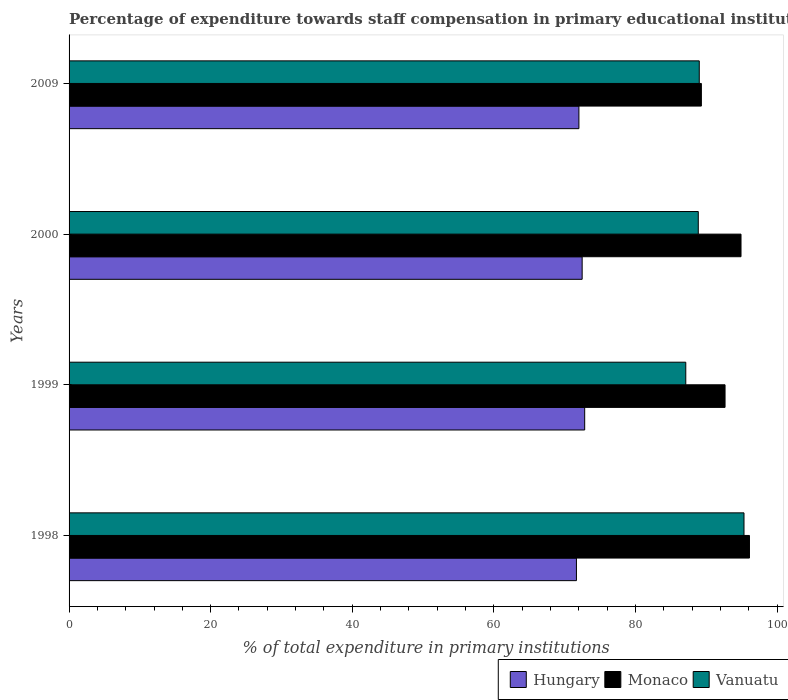How many groups of bars are there?
Offer a very short reply. 4. Are the number of bars on each tick of the Y-axis equal?
Ensure brevity in your answer.  Yes. How many bars are there on the 3rd tick from the bottom?
Make the answer very short. 3. In how many cases, is the number of bars for a given year not equal to the number of legend labels?
Your answer should be compact. 0. What is the percentage of expenditure towards staff compensation in Monaco in 2000?
Give a very brief answer. 94.91. Across all years, what is the maximum percentage of expenditure towards staff compensation in Hungary?
Your response must be concise. 72.83. Across all years, what is the minimum percentage of expenditure towards staff compensation in Hungary?
Make the answer very short. 71.66. What is the total percentage of expenditure towards staff compensation in Monaco in the graph?
Offer a terse response. 372.98. What is the difference between the percentage of expenditure towards staff compensation in Hungary in 1998 and that in 2009?
Make the answer very short. -0.35. What is the difference between the percentage of expenditure towards staff compensation in Monaco in 2009 and the percentage of expenditure towards staff compensation in Vanuatu in 2000?
Make the answer very short. 0.44. What is the average percentage of expenditure towards staff compensation in Hungary per year?
Your answer should be compact. 72.24. In the year 2000, what is the difference between the percentage of expenditure towards staff compensation in Hungary and percentage of expenditure towards staff compensation in Vanuatu?
Provide a succinct answer. -16.4. In how many years, is the percentage of expenditure towards staff compensation in Monaco greater than 92 %?
Ensure brevity in your answer.  3. What is the ratio of the percentage of expenditure towards staff compensation in Monaco in 1998 to that in 1999?
Give a very brief answer. 1.04. Is the difference between the percentage of expenditure towards staff compensation in Hungary in 1999 and 2000 greater than the difference between the percentage of expenditure towards staff compensation in Vanuatu in 1999 and 2000?
Provide a short and direct response. Yes. What is the difference between the highest and the second highest percentage of expenditure towards staff compensation in Vanuatu?
Ensure brevity in your answer.  6.32. What is the difference between the highest and the lowest percentage of expenditure towards staff compensation in Hungary?
Provide a succinct answer. 1.17. What does the 1st bar from the top in 1998 represents?
Give a very brief answer. Vanuatu. What does the 1st bar from the bottom in 2000 represents?
Offer a terse response. Hungary. Is it the case that in every year, the sum of the percentage of expenditure towards staff compensation in Hungary and percentage of expenditure towards staff compensation in Vanuatu is greater than the percentage of expenditure towards staff compensation in Monaco?
Give a very brief answer. Yes. How many bars are there?
Offer a very short reply. 12. Are all the bars in the graph horizontal?
Provide a short and direct response. Yes. How many years are there in the graph?
Your answer should be compact. 4. What is the difference between two consecutive major ticks on the X-axis?
Ensure brevity in your answer.  20. Are the values on the major ticks of X-axis written in scientific E-notation?
Your answer should be compact. No. Does the graph contain grids?
Your answer should be compact. No. Where does the legend appear in the graph?
Your answer should be compact. Bottom right. How are the legend labels stacked?
Offer a terse response. Horizontal. What is the title of the graph?
Offer a terse response. Percentage of expenditure towards staff compensation in primary educational institutions. Does "Libya" appear as one of the legend labels in the graph?
Provide a succinct answer. No. What is the label or title of the X-axis?
Make the answer very short. % of total expenditure in primary institutions. What is the label or title of the Y-axis?
Give a very brief answer. Years. What is the % of total expenditure in primary institutions in Hungary in 1998?
Provide a short and direct response. 71.66. What is the % of total expenditure in primary institutions in Monaco in 1998?
Ensure brevity in your answer.  96.1. What is the % of total expenditure in primary institutions in Vanuatu in 1998?
Provide a succinct answer. 95.33. What is the % of total expenditure in primary institutions in Hungary in 1999?
Keep it short and to the point. 72.83. What is the % of total expenditure in primary institutions of Monaco in 1999?
Make the answer very short. 92.65. What is the % of total expenditure in primary institutions of Vanuatu in 1999?
Provide a succinct answer. 87.11. What is the % of total expenditure in primary institutions of Hungary in 2000?
Provide a short and direct response. 72.47. What is the % of total expenditure in primary institutions of Monaco in 2000?
Your answer should be very brief. 94.91. What is the % of total expenditure in primary institutions of Vanuatu in 2000?
Provide a short and direct response. 88.87. What is the % of total expenditure in primary institutions in Hungary in 2009?
Offer a very short reply. 72.01. What is the % of total expenditure in primary institutions of Monaco in 2009?
Offer a terse response. 89.31. What is the % of total expenditure in primary institutions in Vanuatu in 2009?
Offer a terse response. 89.01. Across all years, what is the maximum % of total expenditure in primary institutions in Hungary?
Keep it short and to the point. 72.83. Across all years, what is the maximum % of total expenditure in primary institutions in Monaco?
Your answer should be compact. 96.1. Across all years, what is the maximum % of total expenditure in primary institutions in Vanuatu?
Give a very brief answer. 95.33. Across all years, what is the minimum % of total expenditure in primary institutions of Hungary?
Provide a succinct answer. 71.66. Across all years, what is the minimum % of total expenditure in primary institutions in Monaco?
Your response must be concise. 89.31. Across all years, what is the minimum % of total expenditure in primary institutions in Vanuatu?
Provide a short and direct response. 87.11. What is the total % of total expenditure in primary institutions in Hungary in the graph?
Your answer should be compact. 288.97. What is the total % of total expenditure in primary institutions in Monaco in the graph?
Offer a very short reply. 372.98. What is the total % of total expenditure in primary institutions of Vanuatu in the graph?
Provide a succinct answer. 360.32. What is the difference between the % of total expenditure in primary institutions of Hungary in 1998 and that in 1999?
Make the answer very short. -1.17. What is the difference between the % of total expenditure in primary institutions in Monaco in 1998 and that in 1999?
Give a very brief answer. 3.45. What is the difference between the % of total expenditure in primary institutions in Vanuatu in 1998 and that in 1999?
Ensure brevity in your answer.  8.22. What is the difference between the % of total expenditure in primary institutions in Hungary in 1998 and that in 2000?
Keep it short and to the point. -0.81. What is the difference between the % of total expenditure in primary institutions of Monaco in 1998 and that in 2000?
Provide a short and direct response. 1.2. What is the difference between the % of total expenditure in primary institutions in Vanuatu in 1998 and that in 2000?
Your answer should be very brief. 6.46. What is the difference between the % of total expenditure in primary institutions of Hungary in 1998 and that in 2009?
Offer a terse response. -0.35. What is the difference between the % of total expenditure in primary institutions in Monaco in 1998 and that in 2009?
Offer a very short reply. 6.79. What is the difference between the % of total expenditure in primary institutions of Vanuatu in 1998 and that in 2009?
Make the answer very short. 6.32. What is the difference between the % of total expenditure in primary institutions in Hungary in 1999 and that in 2000?
Offer a terse response. 0.36. What is the difference between the % of total expenditure in primary institutions of Monaco in 1999 and that in 2000?
Ensure brevity in your answer.  -2.25. What is the difference between the % of total expenditure in primary institutions of Vanuatu in 1999 and that in 2000?
Your answer should be compact. -1.77. What is the difference between the % of total expenditure in primary institutions in Hungary in 1999 and that in 2009?
Your answer should be compact. 0.82. What is the difference between the % of total expenditure in primary institutions of Monaco in 1999 and that in 2009?
Your answer should be very brief. 3.34. What is the difference between the % of total expenditure in primary institutions of Vanuatu in 1999 and that in 2009?
Provide a succinct answer. -1.9. What is the difference between the % of total expenditure in primary institutions in Hungary in 2000 and that in 2009?
Offer a very short reply. 0.46. What is the difference between the % of total expenditure in primary institutions in Monaco in 2000 and that in 2009?
Ensure brevity in your answer.  5.6. What is the difference between the % of total expenditure in primary institutions of Vanuatu in 2000 and that in 2009?
Provide a succinct answer. -0.14. What is the difference between the % of total expenditure in primary institutions in Hungary in 1998 and the % of total expenditure in primary institutions in Monaco in 1999?
Give a very brief answer. -20.99. What is the difference between the % of total expenditure in primary institutions in Hungary in 1998 and the % of total expenditure in primary institutions in Vanuatu in 1999?
Your response must be concise. -15.45. What is the difference between the % of total expenditure in primary institutions in Monaco in 1998 and the % of total expenditure in primary institutions in Vanuatu in 1999?
Provide a succinct answer. 9. What is the difference between the % of total expenditure in primary institutions in Hungary in 1998 and the % of total expenditure in primary institutions in Monaco in 2000?
Give a very brief answer. -23.25. What is the difference between the % of total expenditure in primary institutions in Hungary in 1998 and the % of total expenditure in primary institutions in Vanuatu in 2000?
Provide a short and direct response. -17.21. What is the difference between the % of total expenditure in primary institutions of Monaco in 1998 and the % of total expenditure in primary institutions of Vanuatu in 2000?
Keep it short and to the point. 7.23. What is the difference between the % of total expenditure in primary institutions in Hungary in 1998 and the % of total expenditure in primary institutions in Monaco in 2009?
Ensure brevity in your answer.  -17.65. What is the difference between the % of total expenditure in primary institutions of Hungary in 1998 and the % of total expenditure in primary institutions of Vanuatu in 2009?
Your response must be concise. -17.35. What is the difference between the % of total expenditure in primary institutions in Monaco in 1998 and the % of total expenditure in primary institutions in Vanuatu in 2009?
Offer a very short reply. 7.09. What is the difference between the % of total expenditure in primary institutions in Hungary in 1999 and the % of total expenditure in primary institutions in Monaco in 2000?
Your answer should be compact. -22.08. What is the difference between the % of total expenditure in primary institutions in Hungary in 1999 and the % of total expenditure in primary institutions in Vanuatu in 2000?
Your response must be concise. -16.04. What is the difference between the % of total expenditure in primary institutions of Monaco in 1999 and the % of total expenditure in primary institutions of Vanuatu in 2000?
Offer a terse response. 3.78. What is the difference between the % of total expenditure in primary institutions in Hungary in 1999 and the % of total expenditure in primary institutions in Monaco in 2009?
Make the answer very short. -16.48. What is the difference between the % of total expenditure in primary institutions in Hungary in 1999 and the % of total expenditure in primary institutions in Vanuatu in 2009?
Ensure brevity in your answer.  -16.18. What is the difference between the % of total expenditure in primary institutions in Monaco in 1999 and the % of total expenditure in primary institutions in Vanuatu in 2009?
Offer a very short reply. 3.64. What is the difference between the % of total expenditure in primary institutions in Hungary in 2000 and the % of total expenditure in primary institutions in Monaco in 2009?
Your answer should be very brief. -16.84. What is the difference between the % of total expenditure in primary institutions in Hungary in 2000 and the % of total expenditure in primary institutions in Vanuatu in 2009?
Offer a very short reply. -16.54. What is the difference between the % of total expenditure in primary institutions of Monaco in 2000 and the % of total expenditure in primary institutions of Vanuatu in 2009?
Your answer should be compact. 5.9. What is the average % of total expenditure in primary institutions in Hungary per year?
Offer a very short reply. 72.24. What is the average % of total expenditure in primary institutions in Monaco per year?
Your answer should be compact. 93.24. What is the average % of total expenditure in primary institutions in Vanuatu per year?
Offer a very short reply. 90.08. In the year 1998, what is the difference between the % of total expenditure in primary institutions in Hungary and % of total expenditure in primary institutions in Monaco?
Give a very brief answer. -24.44. In the year 1998, what is the difference between the % of total expenditure in primary institutions of Hungary and % of total expenditure in primary institutions of Vanuatu?
Offer a terse response. -23.67. In the year 1998, what is the difference between the % of total expenditure in primary institutions of Monaco and % of total expenditure in primary institutions of Vanuatu?
Your answer should be compact. 0.77. In the year 1999, what is the difference between the % of total expenditure in primary institutions of Hungary and % of total expenditure in primary institutions of Monaco?
Your answer should be compact. -19.82. In the year 1999, what is the difference between the % of total expenditure in primary institutions in Hungary and % of total expenditure in primary institutions in Vanuatu?
Provide a succinct answer. -14.28. In the year 1999, what is the difference between the % of total expenditure in primary institutions of Monaco and % of total expenditure in primary institutions of Vanuatu?
Provide a succinct answer. 5.55. In the year 2000, what is the difference between the % of total expenditure in primary institutions in Hungary and % of total expenditure in primary institutions in Monaco?
Provide a succinct answer. -22.44. In the year 2000, what is the difference between the % of total expenditure in primary institutions of Hungary and % of total expenditure in primary institutions of Vanuatu?
Provide a short and direct response. -16.4. In the year 2000, what is the difference between the % of total expenditure in primary institutions of Monaco and % of total expenditure in primary institutions of Vanuatu?
Your answer should be very brief. 6.04. In the year 2009, what is the difference between the % of total expenditure in primary institutions of Hungary and % of total expenditure in primary institutions of Monaco?
Provide a short and direct response. -17.3. In the year 2009, what is the difference between the % of total expenditure in primary institutions of Hungary and % of total expenditure in primary institutions of Vanuatu?
Keep it short and to the point. -17. In the year 2009, what is the difference between the % of total expenditure in primary institutions of Monaco and % of total expenditure in primary institutions of Vanuatu?
Your answer should be compact. 0.3. What is the ratio of the % of total expenditure in primary institutions in Hungary in 1998 to that in 1999?
Offer a terse response. 0.98. What is the ratio of the % of total expenditure in primary institutions of Monaco in 1998 to that in 1999?
Your answer should be very brief. 1.04. What is the ratio of the % of total expenditure in primary institutions in Vanuatu in 1998 to that in 1999?
Give a very brief answer. 1.09. What is the ratio of the % of total expenditure in primary institutions of Monaco in 1998 to that in 2000?
Provide a short and direct response. 1.01. What is the ratio of the % of total expenditure in primary institutions of Vanuatu in 1998 to that in 2000?
Make the answer very short. 1.07. What is the ratio of the % of total expenditure in primary institutions of Hungary in 1998 to that in 2009?
Provide a succinct answer. 1. What is the ratio of the % of total expenditure in primary institutions of Monaco in 1998 to that in 2009?
Offer a terse response. 1.08. What is the ratio of the % of total expenditure in primary institutions of Vanuatu in 1998 to that in 2009?
Make the answer very short. 1.07. What is the ratio of the % of total expenditure in primary institutions in Hungary in 1999 to that in 2000?
Your answer should be compact. 1. What is the ratio of the % of total expenditure in primary institutions in Monaco in 1999 to that in 2000?
Your response must be concise. 0.98. What is the ratio of the % of total expenditure in primary institutions of Vanuatu in 1999 to that in 2000?
Keep it short and to the point. 0.98. What is the ratio of the % of total expenditure in primary institutions in Hungary in 1999 to that in 2009?
Your answer should be very brief. 1.01. What is the ratio of the % of total expenditure in primary institutions of Monaco in 1999 to that in 2009?
Provide a short and direct response. 1.04. What is the ratio of the % of total expenditure in primary institutions of Vanuatu in 1999 to that in 2009?
Your answer should be compact. 0.98. What is the ratio of the % of total expenditure in primary institutions of Hungary in 2000 to that in 2009?
Offer a terse response. 1.01. What is the ratio of the % of total expenditure in primary institutions of Monaco in 2000 to that in 2009?
Your response must be concise. 1.06. What is the difference between the highest and the second highest % of total expenditure in primary institutions in Hungary?
Keep it short and to the point. 0.36. What is the difference between the highest and the second highest % of total expenditure in primary institutions in Monaco?
Provide a short and direct response. 1.2. What is the difference between the highest and the second highest % of total expenditure in primary institutions in Vanuatu?
Provide a short and direct response. 6.32. What is the difference between the highest and the lowest % of total expenditure in primary institutions in Hungary?
Your response must be concise. 1.17. What is the difference between the highest and the lowest % of total expenditure in primary institutions of Monaco?
Offer a terse response. 6.79. What is the difference between the highest and the lowest % of total expenditure in primary institutions of Vanuatu?
Your answer should be compact. 8.22. 